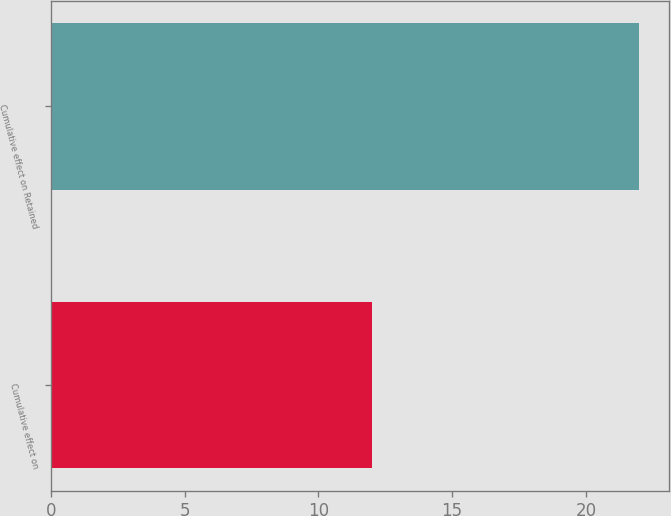Convert chart to OTSL. <chart><loc_0><loc_0><loc_500><loc_500><bar_chart><fcel>Cumulative effect on<fcel>Cumulative effect on Retained<nl><fcel>12<fcel>22<nl></chart> 